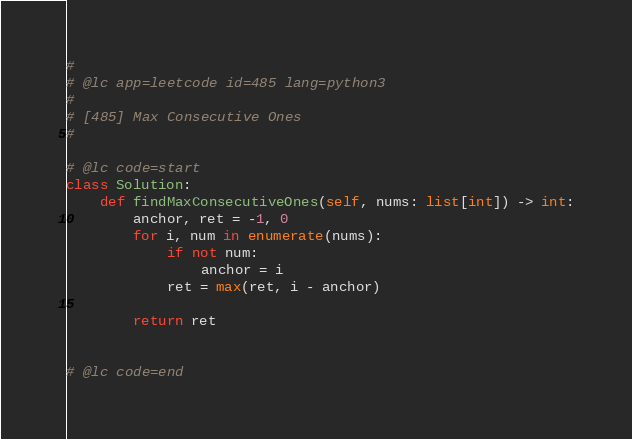Convert code to text. <code><loc_0><loc_0><loc_500><loc_500><_Python_>#
# @lc app=leetcode id=485 lang=python3
#
# [485] Max Consecutive Ones
#

# @lc code=start
class Solution:
    def findMaxConsecutiveOnes(self, nums: list[int]) -> int:
        anchor, ret = -1, 0
        for i, num in enumerate(nums):
            if not num:
                anchor = i
            ret = max(ret, i - anchor)

        return ret


# @lc code=end
</code> 